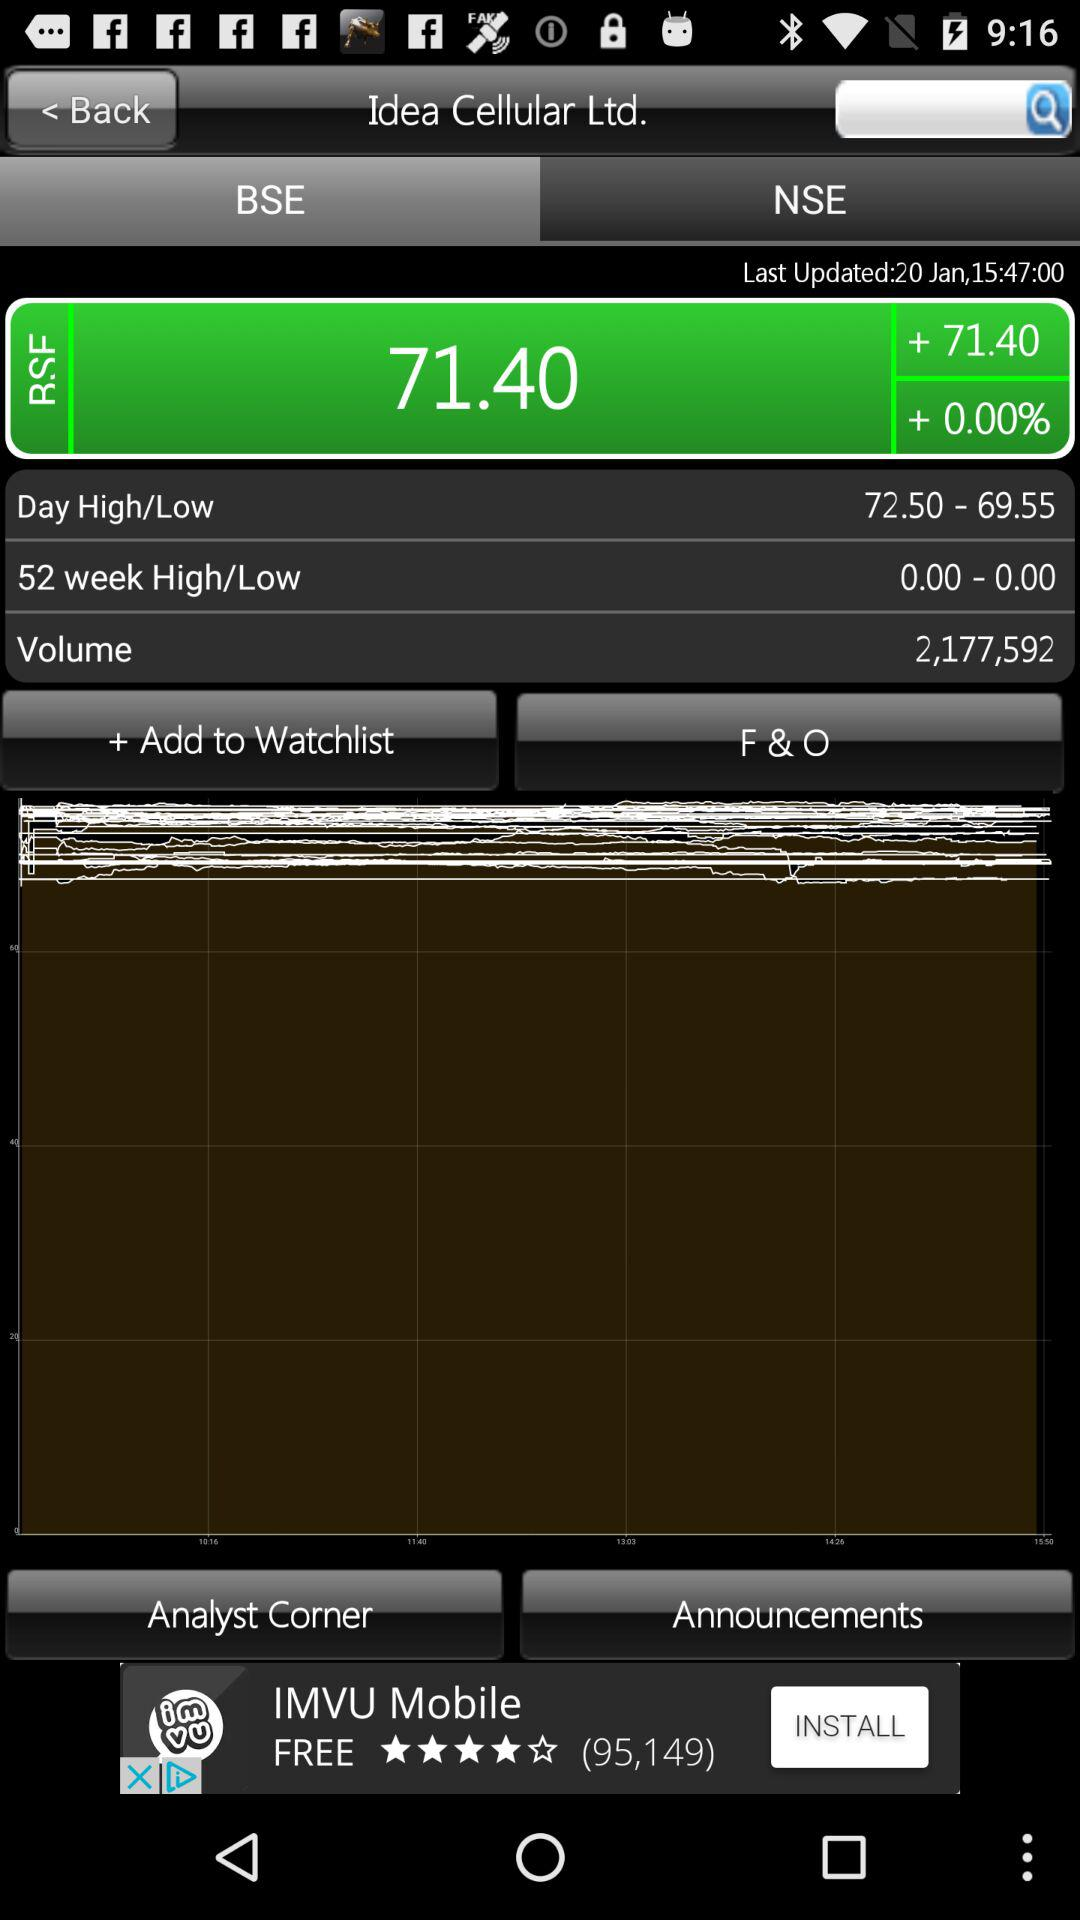What is the total number of BSE points?
When the provided information is insufficient, respond with <no answer>. <no answer> 